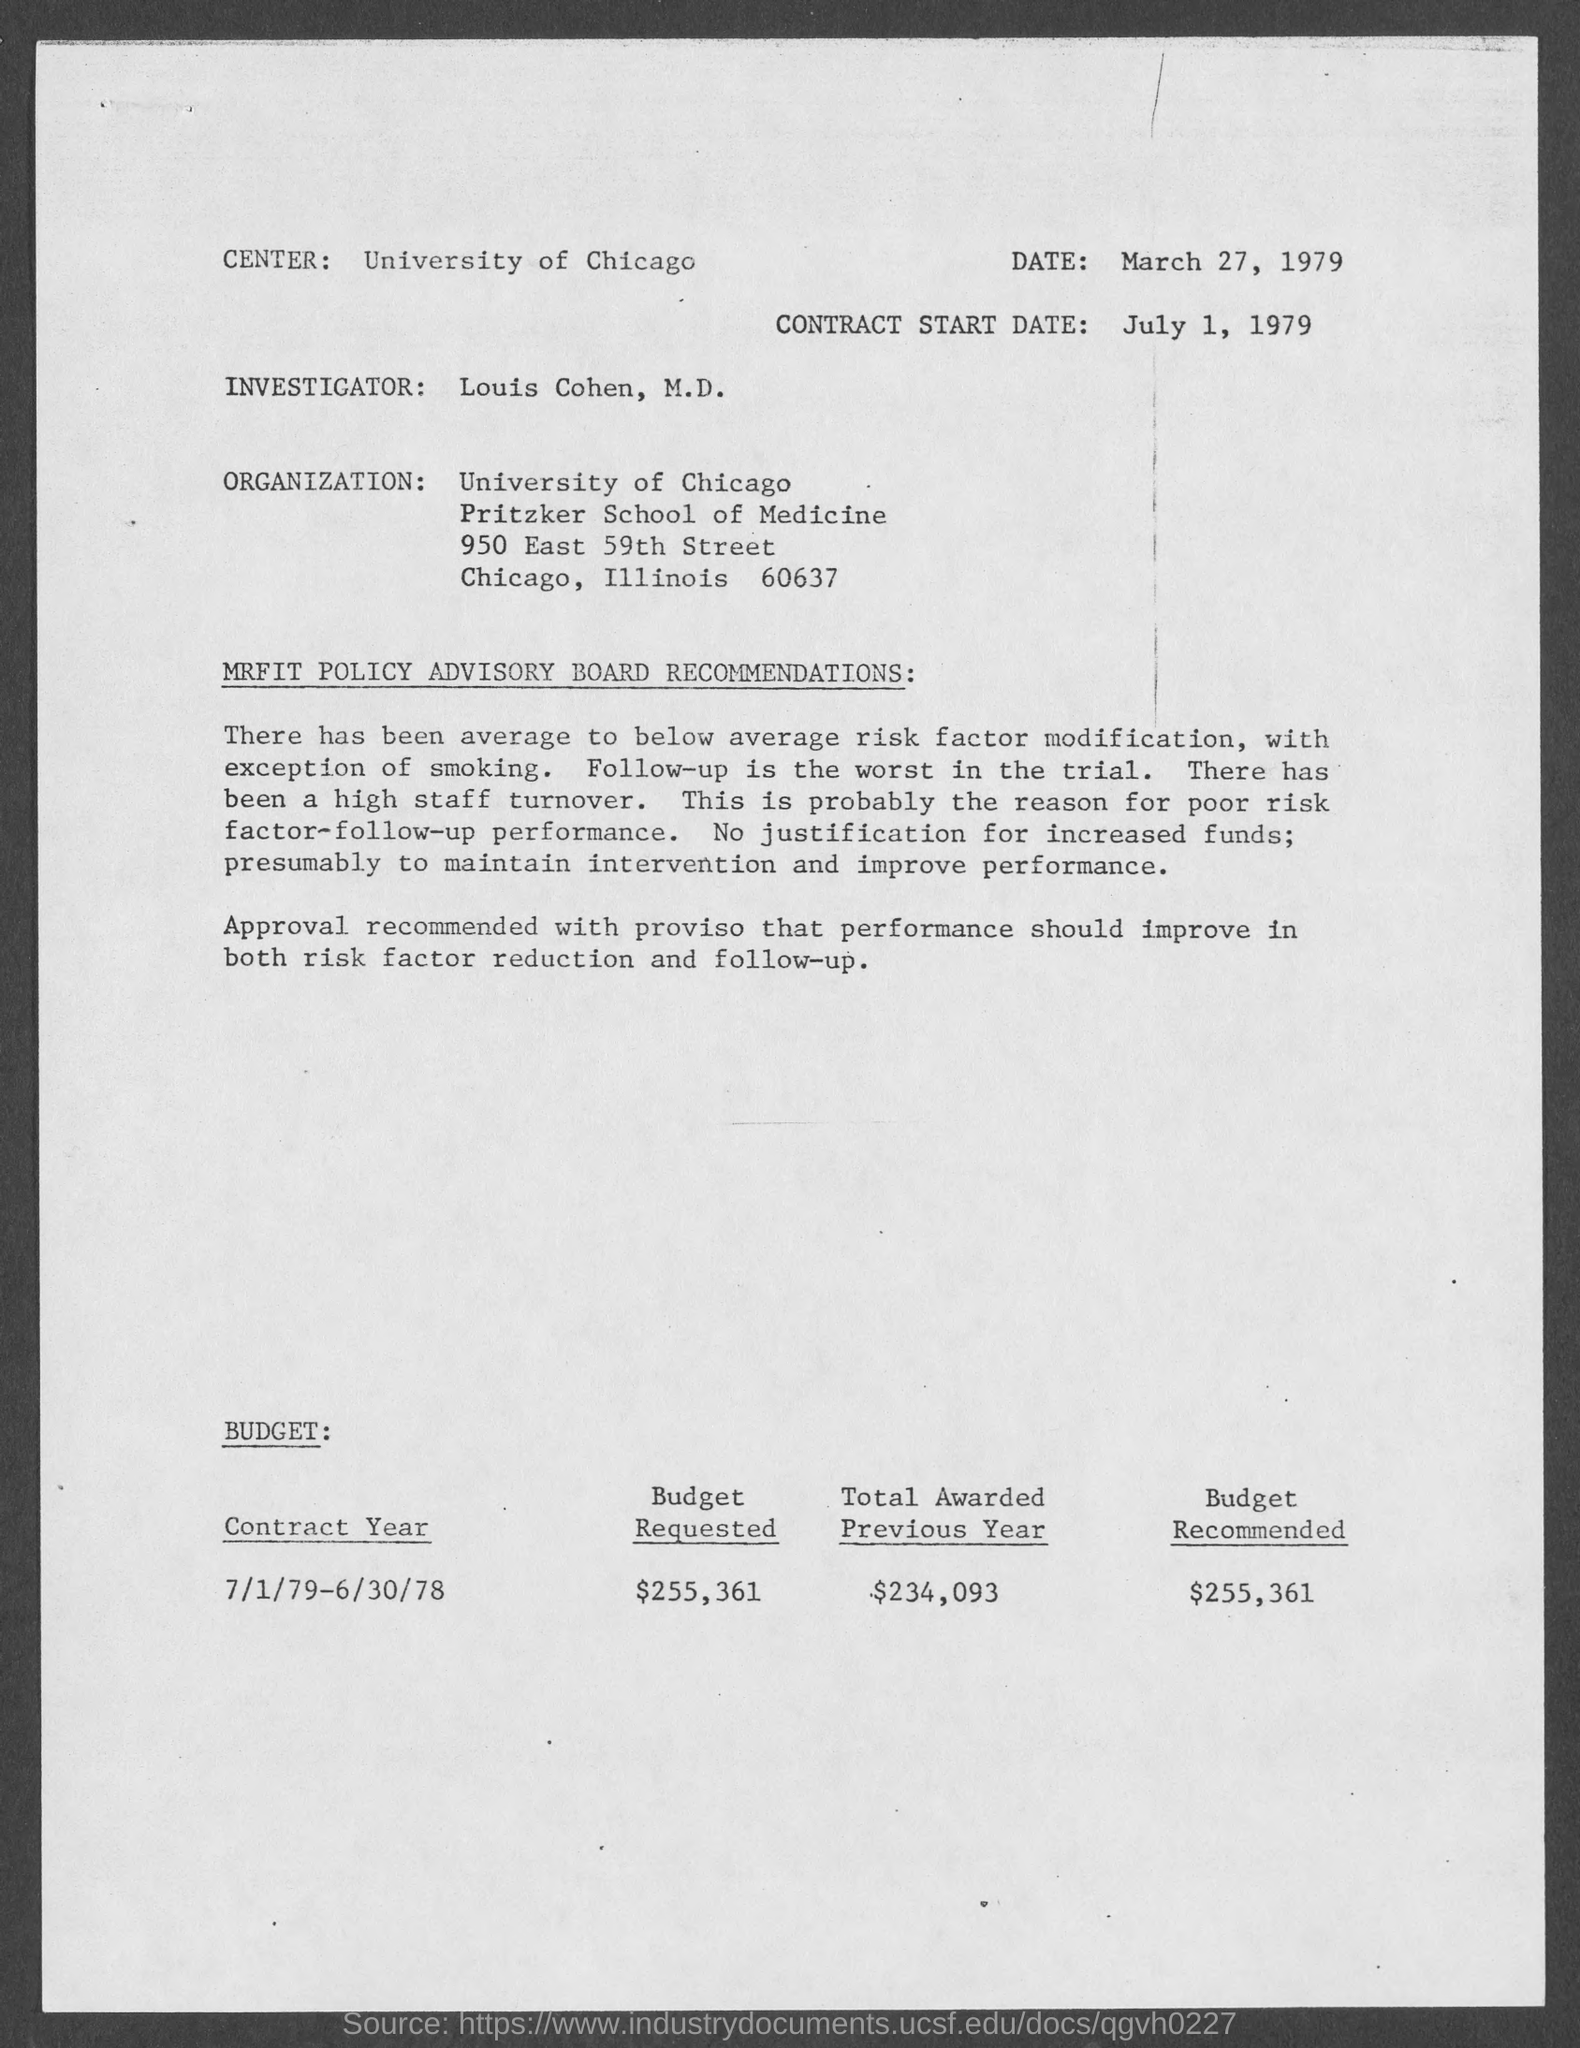When is the document dated?
Your answer should be very brief. March 27, 1979. When is the contract start date?
Offer a terse response. July 1, 1979. Where is the center?
Provide a short and direct response. University of Chicago. Who is the investigator?
Offer a terse response. Louis Cohen, M.D. Which is the organization mentioned?
Keep it short and to the point. University of Chicago. What is the Budget Recommended?
Ensure brevity in your answer.  $255,361. 